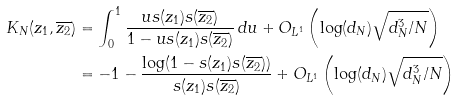<formula> <loc_0><loc_0><loc_500><loc_500>K _ { N } ( z _ { 1 } , \overline { z _ { 2 } } ) & = \int _ { 0 } ^ { 1 } \frac { u s ( z _ { 1 } ) s ( \overline { z _ { 2 } } ) } { 1 - u s ( z _ { 1 } ) s ( \overline { z _ { 2 } } ) } \, d u + O _ { L ^ { 1 } } \left ( \log ( d _ { N } ) \sqrt { d _ { N } ^ { 3 } / N } \right ) \\ & = - 1 - \frac { \log ( 1 - s ( z _ { 1 } ) s ( \overline { z _ { 2 } } ) ) } { s ( z _ { 1 } ) s ( \overline { z _ { 2 } } ) } + O _ { L ^ { 1 } } \left ( \log ( d _ { N } ) \sqrt { d _ { N } ^ { 3 } / N } \right )</formula> 